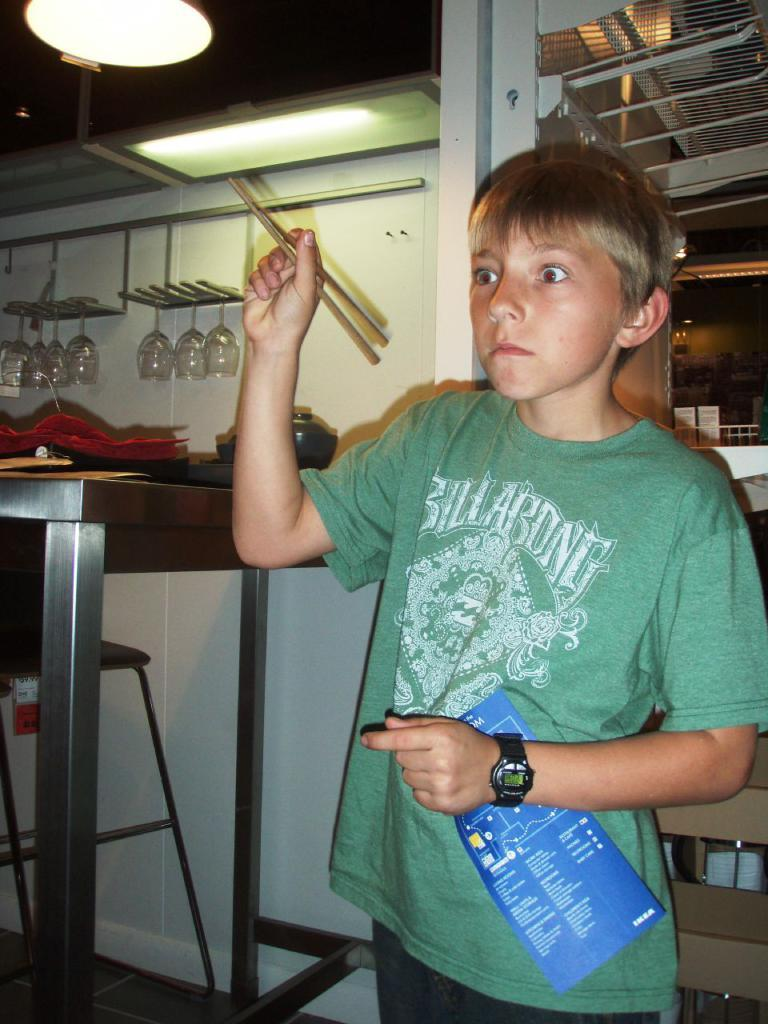Who is present in the image? There is a boy in the image. What is the boy holding in one hand? The boy is holding chopsticks in one hand. What is the boy holding in the other hand? The boy is holding a paper in the other hand. What can be seen in the background of the image? There is a table, a bowl, a light, racks, and a chair in the background of the image. Reasoning: Let'g: Let's think step by step in order to produce the conversation. We start by identifying the main subject in the image, which is the boy. Then, we describe what the boy is holding in each hand. Next, we expand the conversation to include the background of the image, mentioning each object that is visible. Each question is designed to elicit a specific detail about the image that is known from the provided facts. Absurd Question/Answer: What type of cast can be seen on the boy's leg in the image? There is no cast visible on the boy's leg in the image. What trail does the boy follow to reach the location in the image? There is no trail mentioned or visible in the image. 